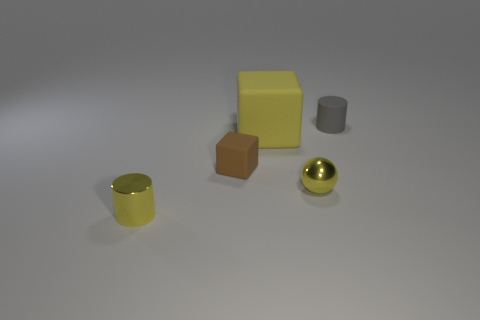Add 4 small spheres. How many objects exist? 9 Subtract all balls. How many objects are left? 4 Add 5 yellow metallic balls. How many yellow metallic balls exist? 6 Subtract 0 green spheres. How many objects are left? 5 Subtract all cylinders. Subtract all brown matte blocks. How many objects are left? 2 Add 3 small yellow metal balls. How many small yellow metal balls are left? 4 